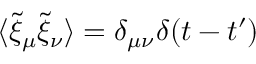Convert formula to latex. <formula><loc_0><loc_0><loc_500><loc_500>\langle \tilde { \xi } _ { \mu } \tilde { \xi } _ { \nu } \rangle = \delta _ { \mu \nu } \delta ( t - t ^ { \prime } )</formula> 